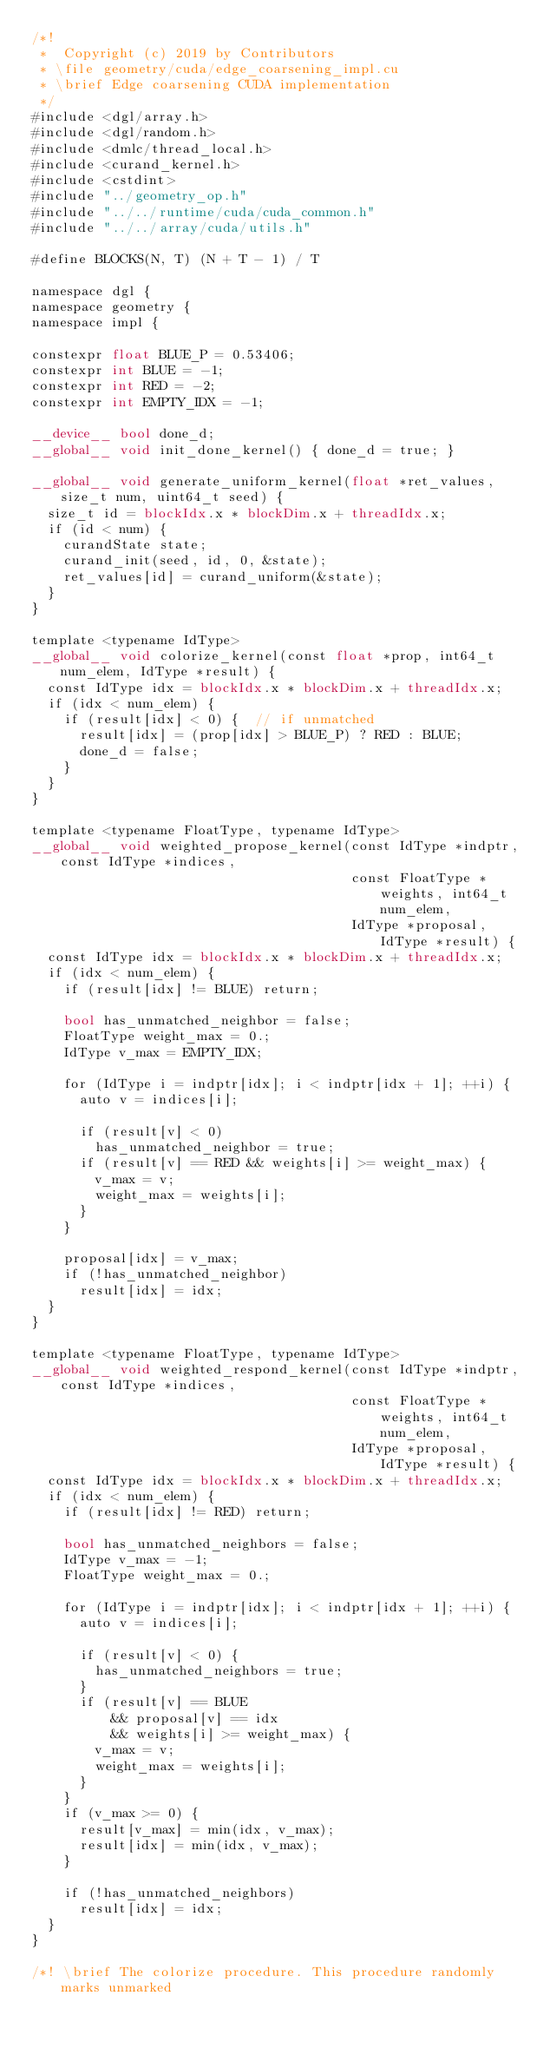<code> <loc_0><loc_0><loc_500><loc_500><_Cuda_>/*!
 *  Copyright (c) 2019 by Contributors
 * \file geometry/cuda/edge_coarsening_impl.cu
 * \brief Edge coarsening CUDA implementation
 */
#include <dgl/array.h>
#include <dgl/random.h>
#include <dmlc/thread_local.h>
#include <curand_kernel.h>
#include <cstdint>
#include "../geometry_op.h"
#include "../../runtime/cuda/cuda_common.h"
#include "../../array/cuda/utils.h"

#define BLOCKS(N, T) (N + T - 1) / T

namespace dgl {
namespace geometry {
namespace impl {

constexpr float BLUE_P = 0.53406;
constexpr int BLUE = -1;
constexpr int RED = -2;
constexpr int EMPTY_IDX = -1;

__device__ bool done_d;
__global__ void init_done_kernel() { done_d = true; }

__global__ void generate_uniform_kernel(float *ret_values, size_t num, uint64_t seed) {
  size_t id = blockIdx.x * blockDim.x + threadIdx.x;
  if (id < num) {
    curandState state;
    curand_init(seed, id, 0, &state);
    ret_values[id] = curand_uniform(&state);
  }
}

template <typename IdType>
__global__ void colorize_kernel(const float *prop, int64_t num_elem, IdType *result) {
  const IdType idx = blockIdx.x * blockDim.x + threadIdx.x;
  if (idx < num_elem) {
    if (result[idx] < 0) {  // if unmatched
      result[idx] = (prop[idx] > BLUE_P) ? RED : BLUE;
      done_d = false;
    }
  }
}

template <typename FloatType, typename IdType>
__global__ void weighted_propose_kernel(const IdType *indptr, const IdType *indices,
                                        const FloatType *weights, int64_t num_elem,
                                        IdType *proposal, IdType *result) {
  const IdType idx = blockIdx.x * blockDim.x + threadIdx.x;
  if (idx < num_elem) {
    if (result[idx] != BLUE) return;

    bool has_unmatched_neighbor = false;
    FloatType weight_max = 0.;
    IdType v_max = EMPTY_IDX;

    for (IdType i = indptr[idx]; i < indptr[idx + 1]; ++i) {
      auto v = indices[i];

      if (result[v] < 0)
        has_unmatched_neighbor = true;
      if (result[v] == RED && weights[i] >= weight_max) {
        v_max = v;
        weight_max = weights[i];
      }
    }

    proposal[idx] = v_max;
    if (!has_unmatched_neighbor)
      result[idx] = idx;
  }
}

template <typename FloatType, typename IdType>
__global__ void weighted_respond_kernel(const IdType *indptr, const IdType *indices,
                                        const FloatType *weights, int64_t num_elem,
                                        IdType *proposal, IdType *result) {
  const IdType idx = blockIdx.x * blockDim.x + threadIdx.x;
  if (idx < num_elem) {
    if (result[idx] != RED) return;

    bool has_unmatched_neighbors = false;
    IdType v_max = -1;
    FloatType weight_max = 0.;

    for (IdType i = indptr[idx]; i < indptr[idx + 1]; ++i) {
      auto v = indices[i];

      if (result[v] < 0) {
        has_unmatched_neighbors = true;
      }
      if (result[v] == BLUE
          && proposal[v] == idx
          && weights[i] >= weight_max) {
        v_max = v;
        weight_max = weights[i];
      }
    }
    if (v_max >= 0) {
      result[v_max] = min(idx, v_max);
      result[idx] = min(idx, v_max);
    }

    if (!has_unmatched_neighbors)
      result[idx] = idx;
  }
}

/*! \brief The colorize procedure. This procedure randomly marks unmarked</code> 